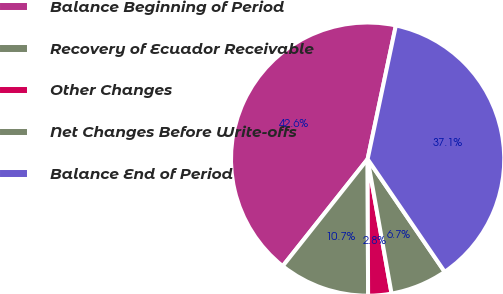Convert chart. <chart><loc_0><loc_0><loc_500><loc_500><pie_chart><fcel>Balance Beginning of Period<fcel>Recovery of Ecuador Receivable<fcel>Other Changes<fcel>Net Changes Before Write-offs<fcel>Balance End of Period<nl><fcel>42.64%<fcel>10.73%<fcel>2.75%<fcel>6.74%<fcel>37.14%<nl></chart> 